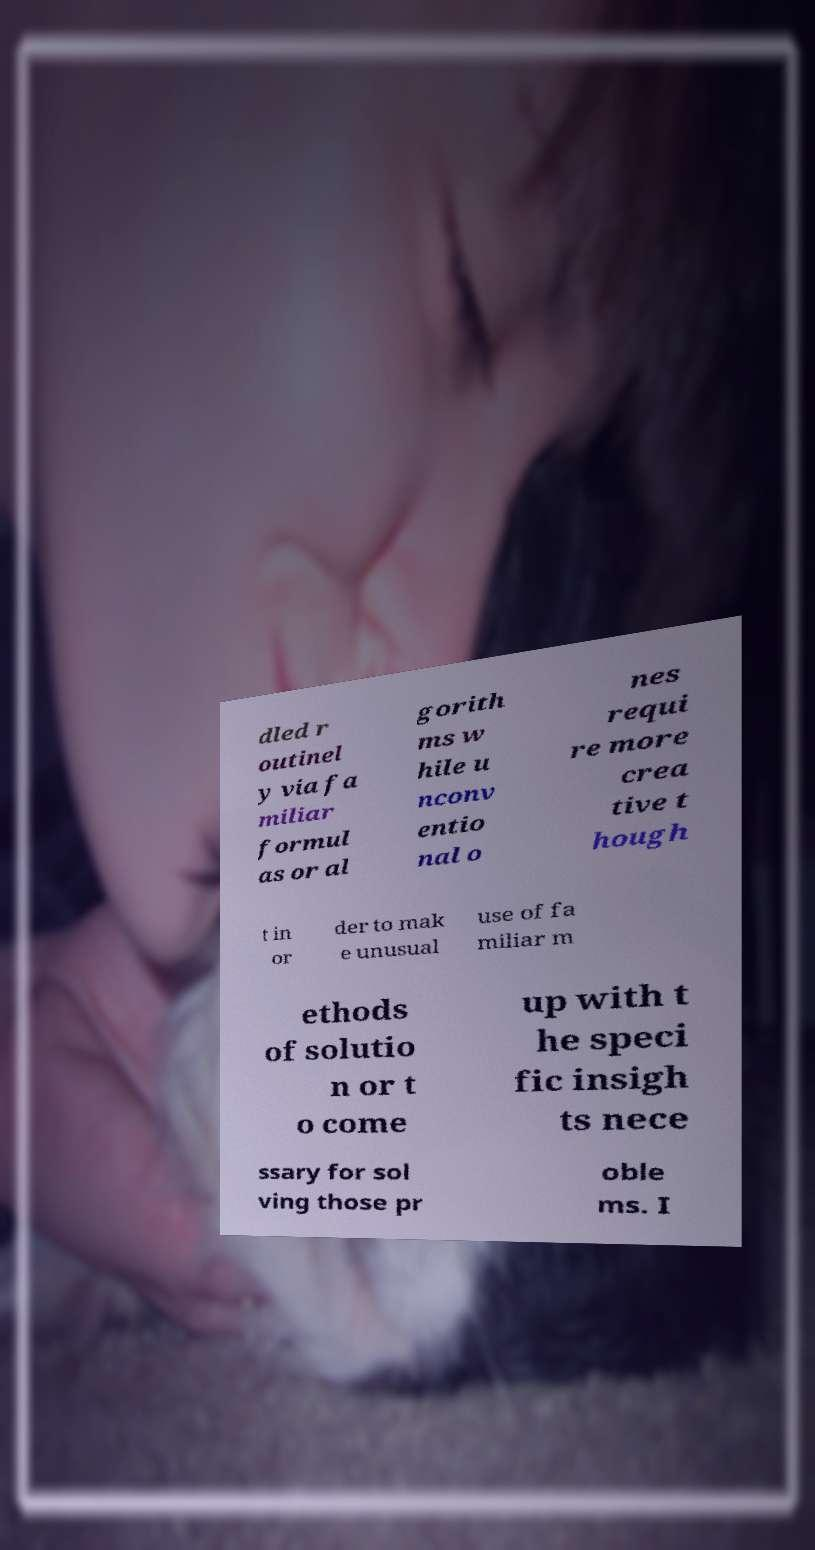For documentation purposes, I need the text within this image transcribed. Could you provide that? dled r outinel y via fa miliar formul as or al gorith ms w hile u nconv entio nal o nes requi re more crea tive t hough t in or der to mak e unusual use of fa miliar m ethods of solutio n or t o come up with t he speci fic insigh ts nece ssary for sol ving those pr oble ms. I 